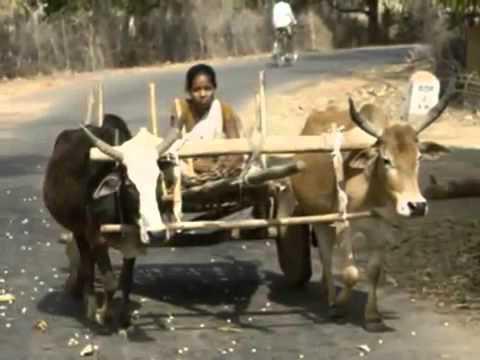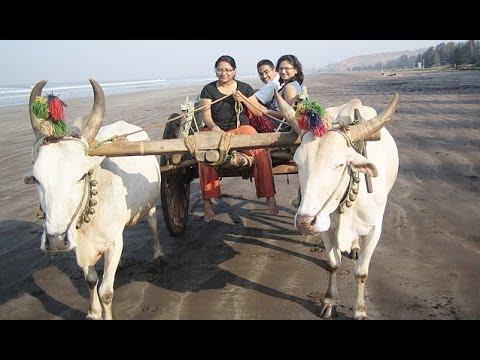The first image is the image on the left, the second image is the image on the right. For the images shown, is this caption "Four oxen are pulling carts with at least one person riding in them." true? Answer yes or no. Yes. The first image is the image on the left, the second image is the image on the right. Considering the images on both sides, is "The oxen in the image on the right are wearing decorative headgear." valid? Answer yes or no. Yes. 